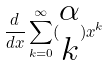<formula> <loc_0><loc_0><loc_500><loc_500>\frac { d } { d x } \sum _ { k = 0 } ^ { \infty } ( \begin{matrix} \alpha \\ k \end{matrix} ) x ^ { k }</formula> 